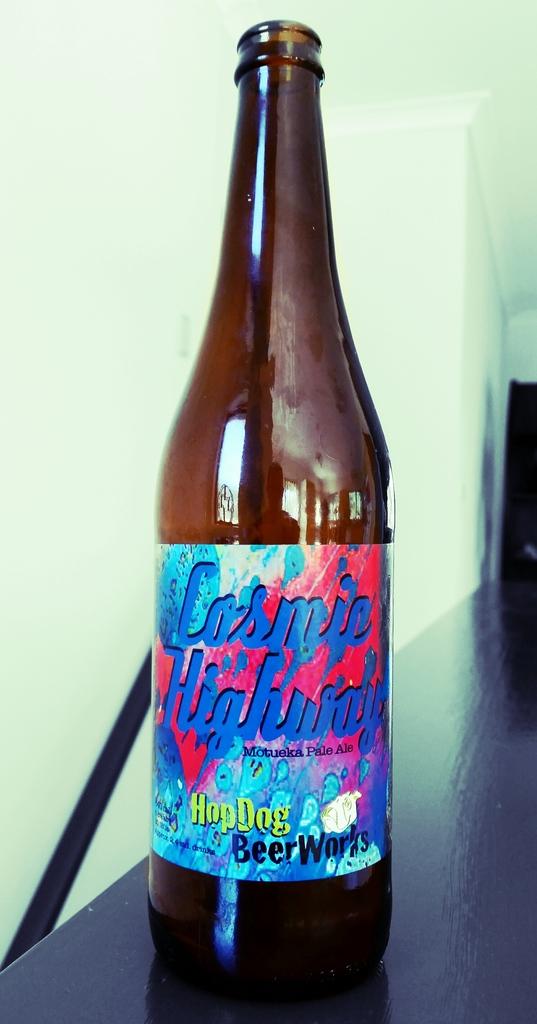Is this an non alcoholic or a alcoholic drink?
Your answer should be compact. Alcoholic. What is the word in green text at the bottom?
Ensure brevity in your answer.  Hopdog. 